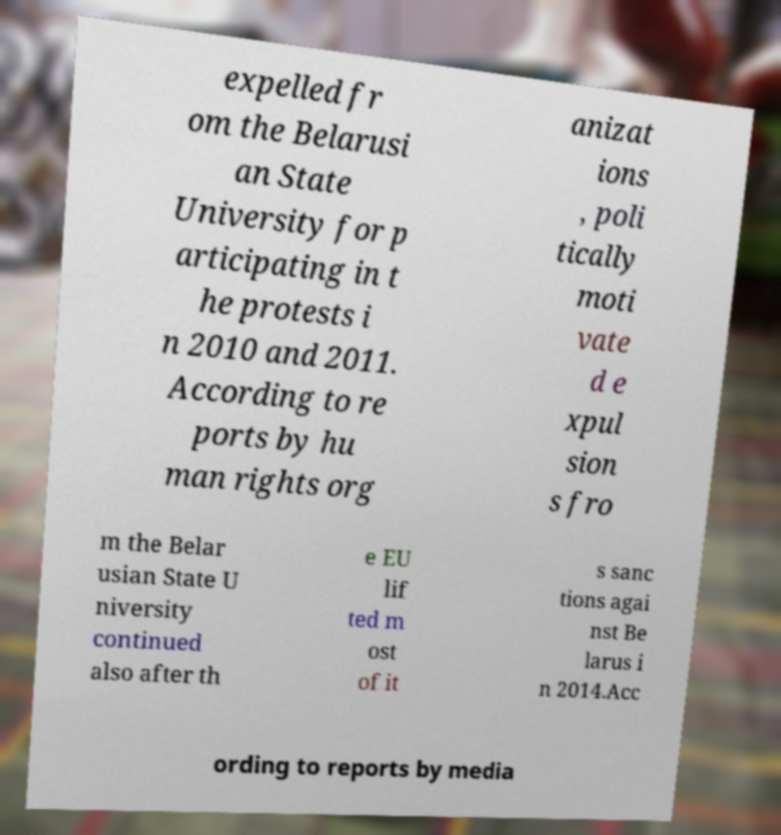I need the written content from this picture converted into text. Can you do that? expelled fr om the Belarusi an State University for p articipating in t he protests i n 2010 and 2011. According to re ports by hu man rights org anizat ions , poli tically moti vate d e xpul sion s fro m the Belar usian State U niversity continued also after th e EU lif ted m ost of it s sanc tions agai nst Be larus i n 2014.Acc ording to reports by media 